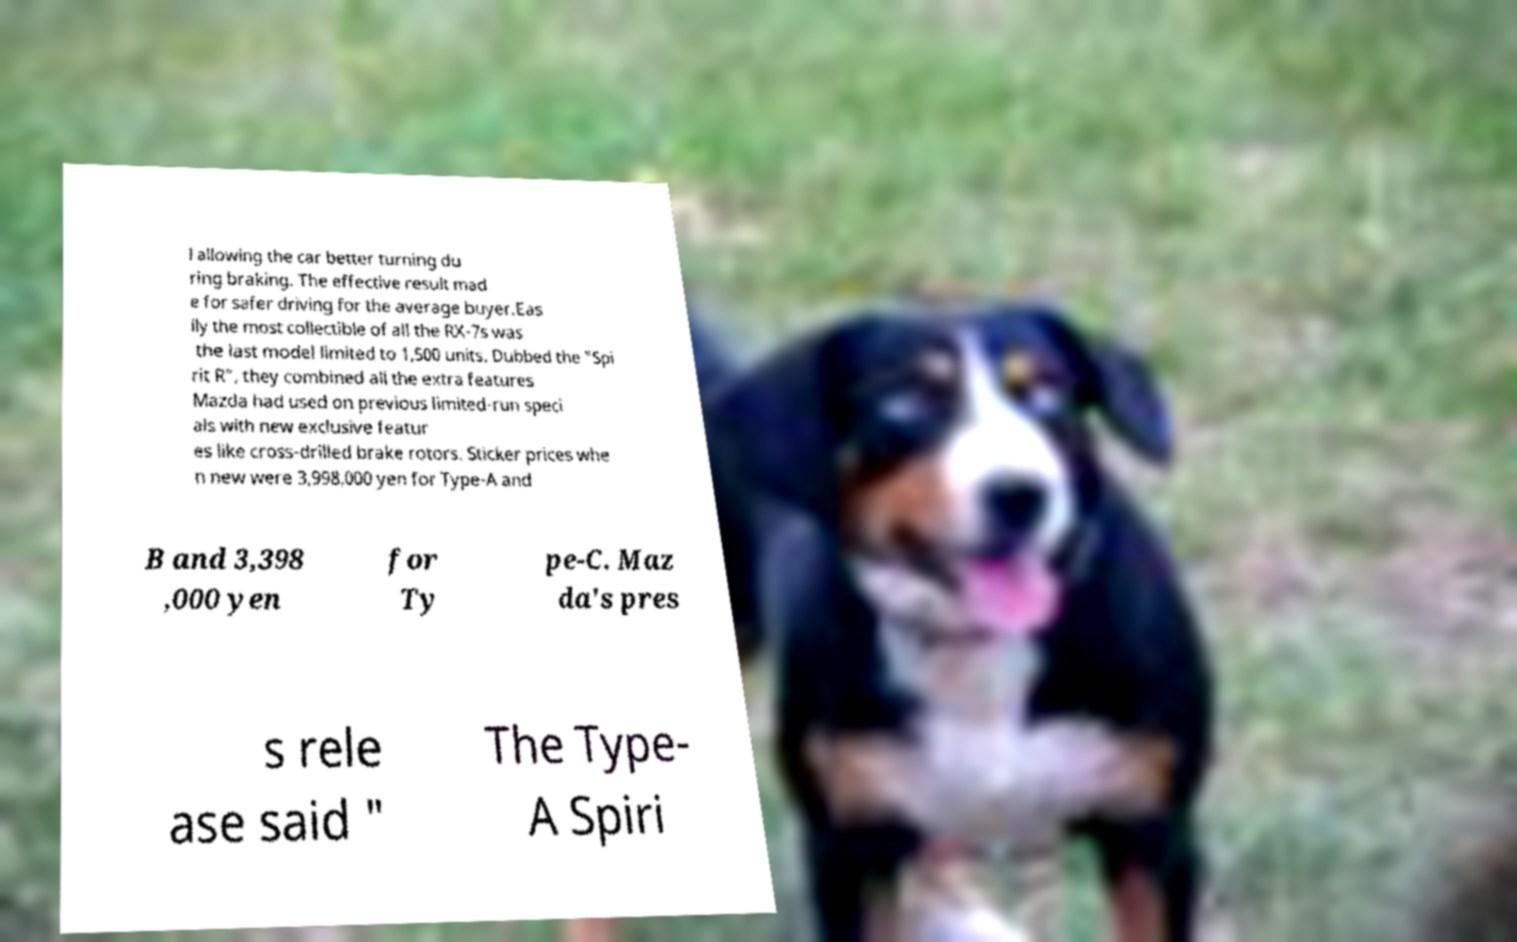Could you extract and type out the text from this image? l allowing the car better turning du ring braking. The effective result mad e for safer driving for the average buyer.Eas ily the most collectible of all the RX-7s was the last model limited to 1,500 units. Dubbed the "Spi rit R", they combined all the extra features Mazda had used on previous limited-run speci als with new exclusive featur es like cross-drilled brake rotors. Sticker prices whe n new were 3,998,000 yen for Type-A and B and 3,398 ,000 yen for Ty pe-C. Maz da's pres s rele ase said " The Type- A Spiri 